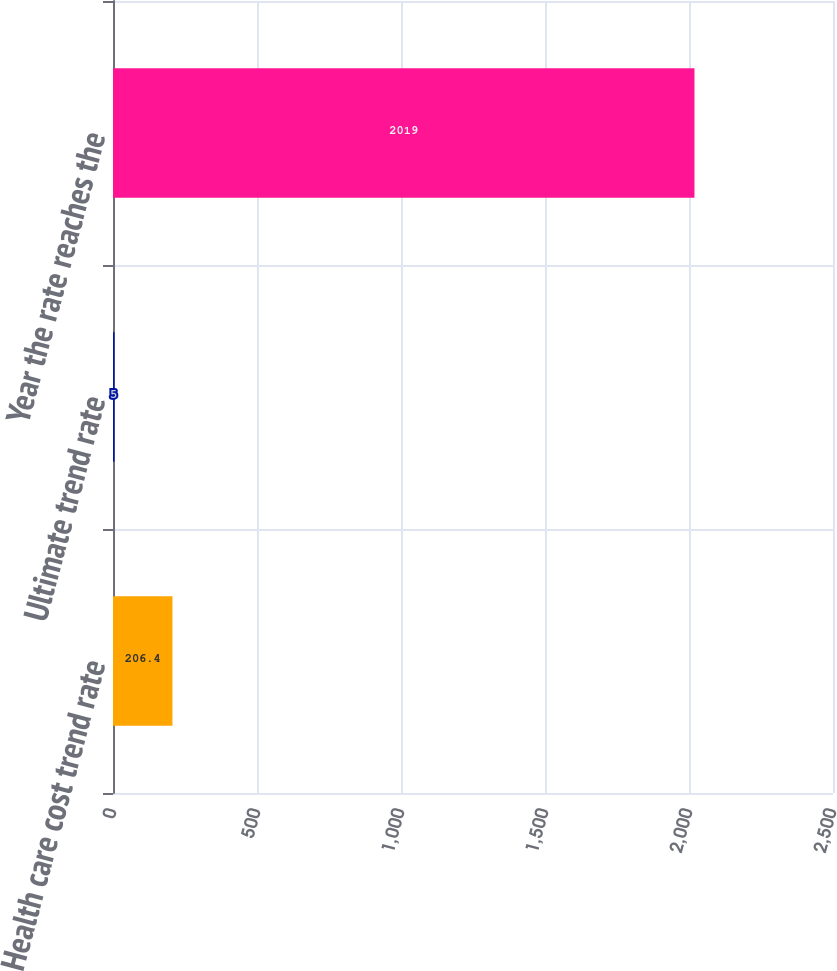Convert chart. <chart><loc_0><loc_0><loc_500><loc_500><bar_chart><fcel>Health care cost trend rate<fcel>Ultimate trend rate<fcel>Year the rate reaches the<nl><fcel>206.4<fcel>5<fcel>2019<nl></chart> 